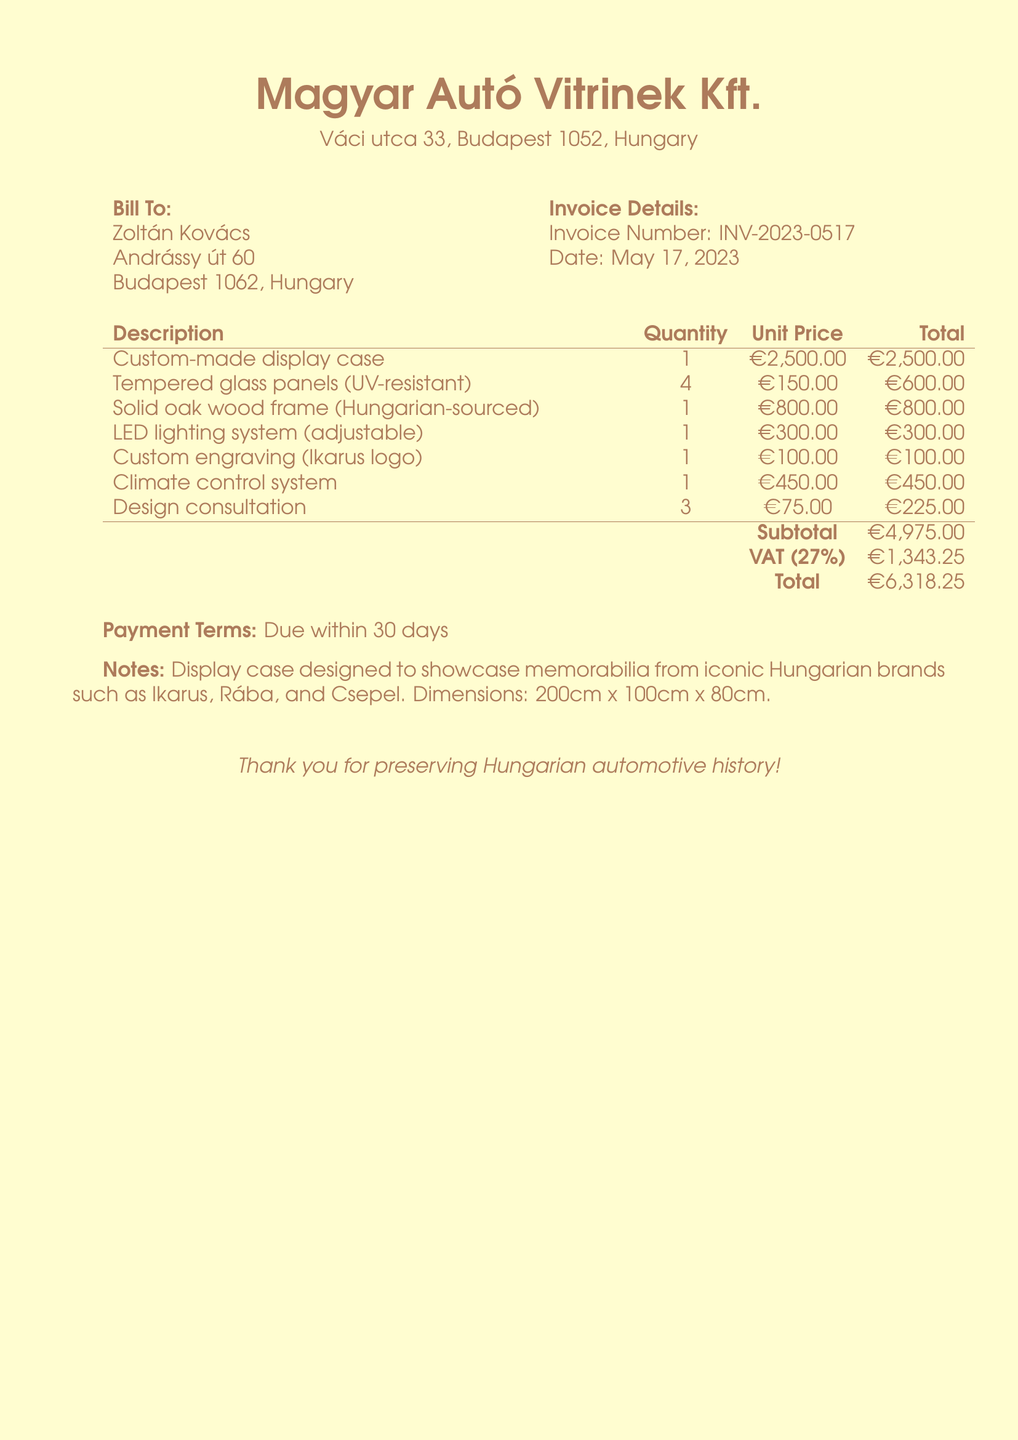what is the invoice number? The invoice number is specifically listed in the document to identify this transaction.
Answer: INV-2023-0517 what is the total amount due? The total amount entails the sum of the subtotal and VAT as shown at the bottom of the invoice.
Answer: €6,318.25 who is the bill addressed to? The recipient's name is explicitly mentioned at the beginning of the invoice.
Answer: Zoltán Kovács what is the VAT percentage applied? The VAT percentage is clearly stated in the invoice, indicating the applicable tax rate.
Answer: 27% how much did the custom-made display case cost? The specific cost of the custom-made display case is itemized in the list of charges.
Answer: €2,500.00 what materials are used for the display case? The materials are specified in the description section, indicating what was used in the construction.
Answer: Tempered glass, solid oak wood how many tempered glass panels were included? The quantity of tempered glass panels is mentioned next to the description of the item in the invoice.
Answer: 4 when is the payment due? The payment terms specify the deadline for payment and are detailed towards the bottom of the document.
Answer: Within 30 days what is the purpose of the display case? The notes section describes the intended use of the display case as it relates to the collector's items.
Answer: To showcase memorabilia from iconic Hungarian brands 